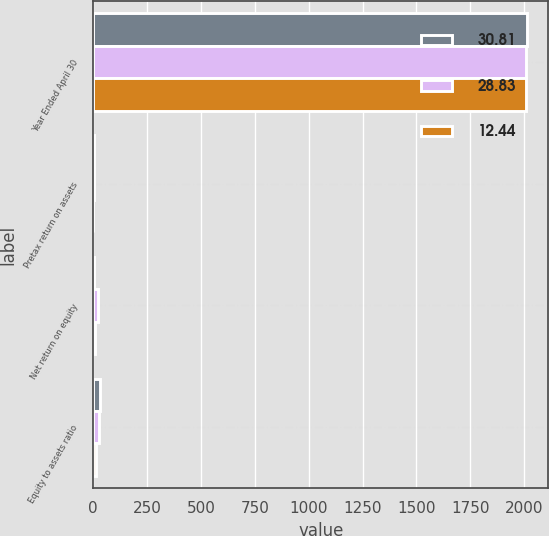Convert chart to OTSL. <chart><loc_0><loc_0><loc_500><loc_500><stacked_bar_chart><ecel><fcel>Year Ended April 30<fcel>Pretax return on assets<fcel>Net return on equity<fcel>Equity to assets ratio<nl><fcel>30.81<fcel>2011<fcel>2.36<fcel>5.43<fcel>30.81<nl><fcel>28.83<fcel>2010<fcel>2.12<fcel>21.04<fcel>28.83<nl><fcel>12.44<fcel>2009<fcel>1.03<fcel>6.67<fcel>12.44<nl></chart> 